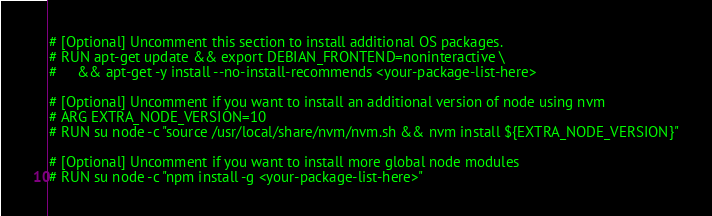Convert code to text. <code><loc_0><loc_0><loc_500><loc_500><_Dockerfile_># [Optional] Uncomment this section to install additional OS packages.
# RUN apt-get update && export DEBIAN_FRONTEND=noninteractive \
#     && apt-get -y install --no-install-recommends <your-package-list-here>

# [Optional] Uncomment if you want to install an additional version of node using nvm
# ARG EXTRA_NODE_VERSION=10
# RUN su node -c "source /usr/local/share/nvm/nvm.sh && nvm install ${EXTRA_NODE_VERSION}"

# [Optional] Uncomment if you want to install more global node modules
# RUN su node -c "npm install -g <your-package-list-here>"
</code> 